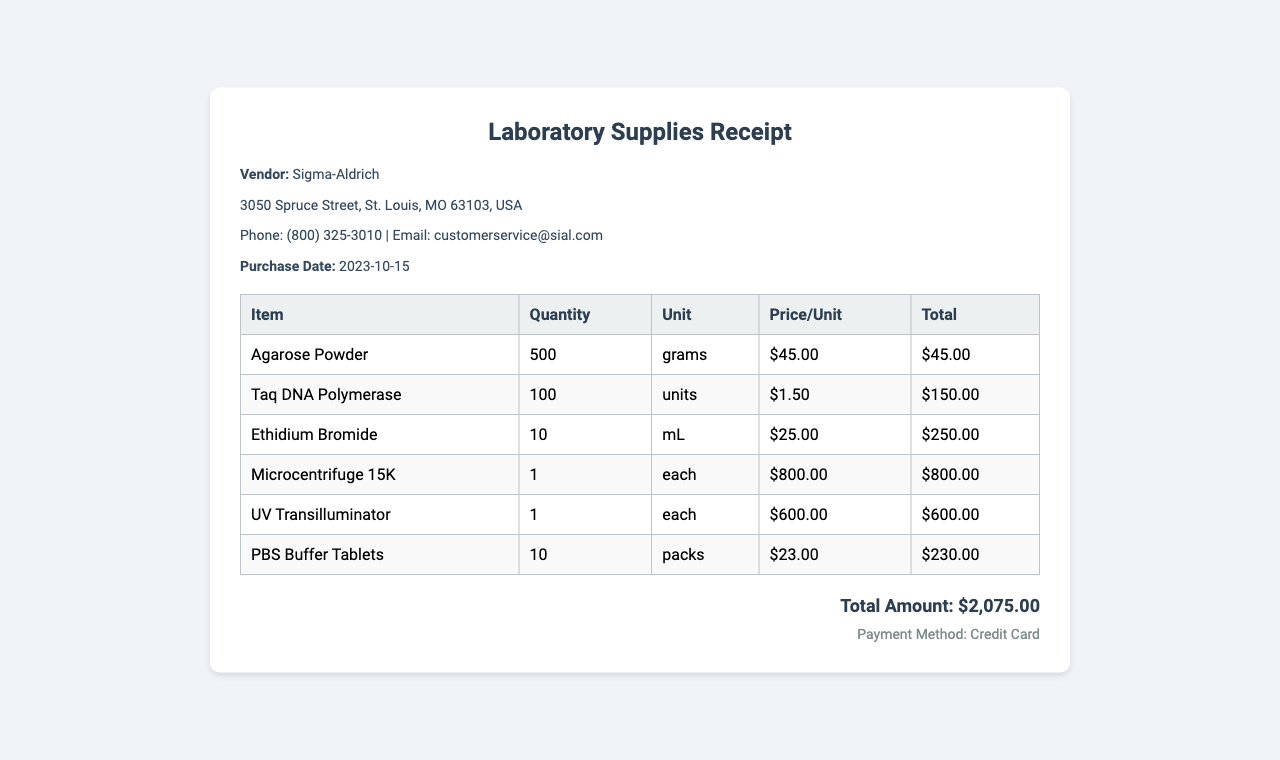What is the vendor's name? The vendor's name is mentioned prominently at the beginning of the vendor information section.
Answer: Sigma-Aldrich What is the purchase date? The purchase date is specified directly beneath the vendor information section.
Answer: 2023-10-15 How many units of Taq DNA Polymerase were purchased? The quantity of Taq DNA Polymerase is listed in the items table along with the other reagents and equipment.
Answer: 100 What is the total amount of the receipt? The total amount is clearly stated at the bottom of the receipt, summarizing the overall cost of all items.
Answer: $2,075.00 What is the payment method used? The payment method is provided in a distinct section towards the end of the document.
Answer: Credit Card 